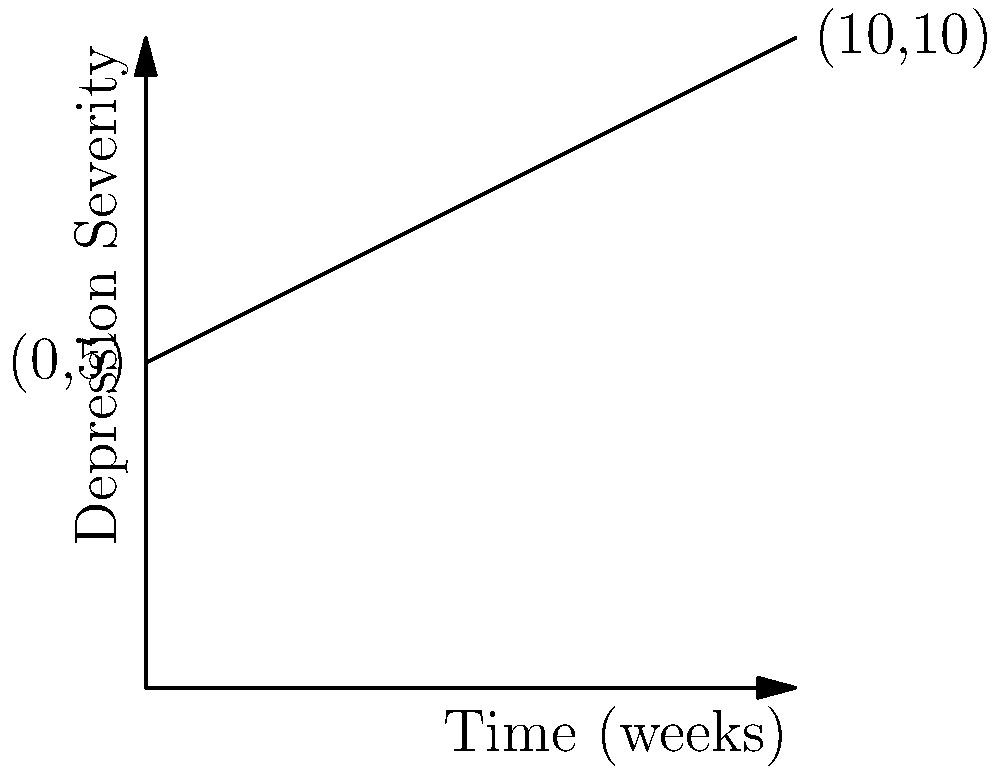In a study tracking the progression of depressive symptoms during a major depressive episode, the severity of depression is plotted against time. The line representing this progression passes through the points (0,5) and (10,10), where the x-axis represents time in weeks and the y-axis represents depression severity on a scale of 0-10. What is the slope of this line, and what does it indicate about the rate of symptom progression? To determine the slope of the line, we can use the slope formula:

$$ m = \frac{y_2 - y_1}{x_2 - x_1} $$

Where $(x_1, y_1)$ is the first point and $(x_2, y_2)$ is the second point.

Given:
$(x_1, y_1) = (0, 5)$
$(x_2, y_2) = (10, 10)$

Substituting these values into the formula:

$$ m = \frac{10 - 5}{10 - 0} = \frac{5}{10} = 0.5 $$

The slope of the line is 0.5.

Interpretation:
The slope represents the rate of change in depression severity over time. A slope of 0.5 indicates that for each week that passes (x-axis), the depression severity (y-axis) increases by 0.5 units. This suggests a steady worsening of depressive symptoms over the 10-week period.

In the context of a major depressive episode, this slope indicates a gradual but consistent increase in symptom severity. This information could be valuable for clinicians in understanding the typical progression of symptoms and in planning appropriate interventions.
Answer: Slope = 0.5; indicates depression severity increases by 0.5 units per week. 